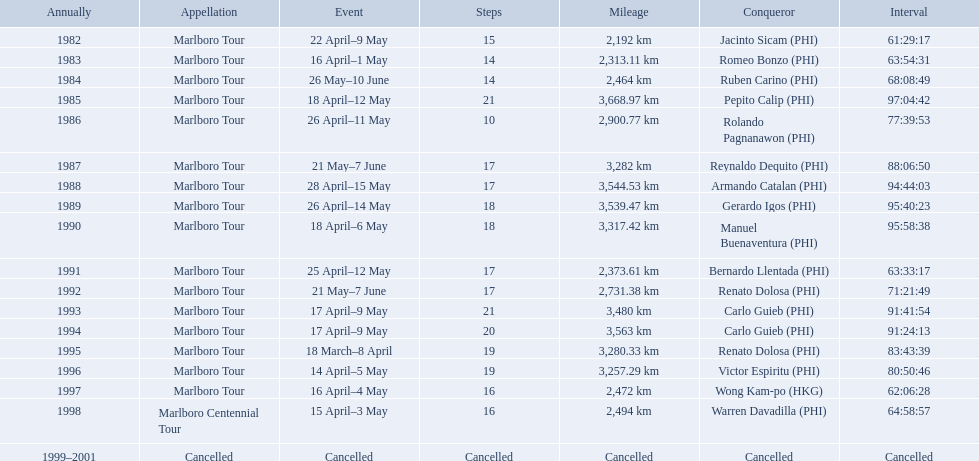What race did warren davadilla compete in in 1998? Marlboro Centennial Tour. How long did it take davadilla to complete the marlboro centennial tour? 64:58:57. Could you help me parse every detail presented in this table? {'header': ['Annually', 'Appellation', 'Event', 'Steps', 'Mileage', 'Conqueror', 'Interval'], 'rows': [['1982', 'Marlboro Tour', '22 April–9 May', '15', '2,192\xa0km', 'Jacinto Sicam\xa0(PHI)', '61:29:17'], ['1983', 'Marlboro Tour', '16 April–1 May', '14', '2,313.11\xa0km', 'Romeo Bonzo\xa0(PHI)', '63:54:31'], ['1984', 'Marlboro Tour', '26 May–10 June', '14', '2,464\xa0km', 'Ruben Carino\xa0(PHI)', '68:08:49'], ['1985', 'Marlboro Tour', '18 April–12 May', '21', '3,668.97\xa0km', 'Pepito Calip\xa0(PHI)', '97:04:42'], ['1986', 'Marlboro Tour', '26 April–11 May', '10', '2,900.77\xa0km', 'Rolando Pagnanawon\xa0(PHI)', '77:39:53'], ['1987', 'Marlboro Tour', '21 May–7 June', '17', '3,282\xa0km', 'Reynaldo Dequito\xa0(PHI)', '88:06:50'], ['1988', 'Marlboro Tour', '28 April–15 May', '17', '3,544.53\xa0km', 'Armando Catalan\xa0(PHI)', '94:44:03'], ['1989', 'Marlboro Tour', '26 April–14 May', '18', '3,539.47\xa0km', 'Gerardo Igos\xa0(PHI)', '95:40:23'], ['1990', 'Marlboro Tour', '18 April–6 May', '18', '3,317.42\xa0km', 'Manuel Buenaventura\xa0(PHI)', '95:58:38'], ['1991', 'Marlboro Tour', '25 April–12 May', '17', '2,373.61\xa0km', 'Bernardo Llentada\xa0(PHI)', '63:33:17'], ['1992', 'Marlboro Tour', '21 May–7 June', '17', '2,731.38\xa0km', 'Renato Dolosa\xa0(PHI)', '71:21:49'], ['1993', 'Marlboro Tour', '17 April–9 May', '21', '3,480\xa0km', 'Carlo Guieb\xa0(PHI)', '91:41:54'], ['1994', 'Marlboro Tour', '17 April–9 May', '20', '3,563\xa0km', 'Carlo Guieb\xa0(PHI)', '91:24:13'], ['1995', 'Marlboro Tour', '18 March–8 April', '19', '3,280.33\xa0km', 'Renato Dolosa\xa0(PHI)', '83:43:39'], ['1996', 'Marlboro Tour', '14 April–5 May', '19', '3,257.29\xa0km', 'Victor Espiritu\xa0(PHI)', '80:50:46'], ['1997', 'Marlboro Tour', '16 April–4 May', '16', '2,472\xa0km', 'Wong Kam-po\xa0(HKG)', '62:06:28'], ['1998', 'Marlboro Centennial Tour', '15 April–3 May', '16', '2,494\xa0km', 'Warren Davadilla\xa0(PHI)', '64:58:57'], ['1999–2001', 'Cancelled', 'Cancelled', 'Cancelled', 'Cancelled', 'Cancelled', 'Cancelled']]} Which year did warren davdilla (w.d.) appear? 1998. What tour did w.d. complete? Marlboro Centennial Tour. What is the time recorded in the same row as w.d.? 64:58:57. 